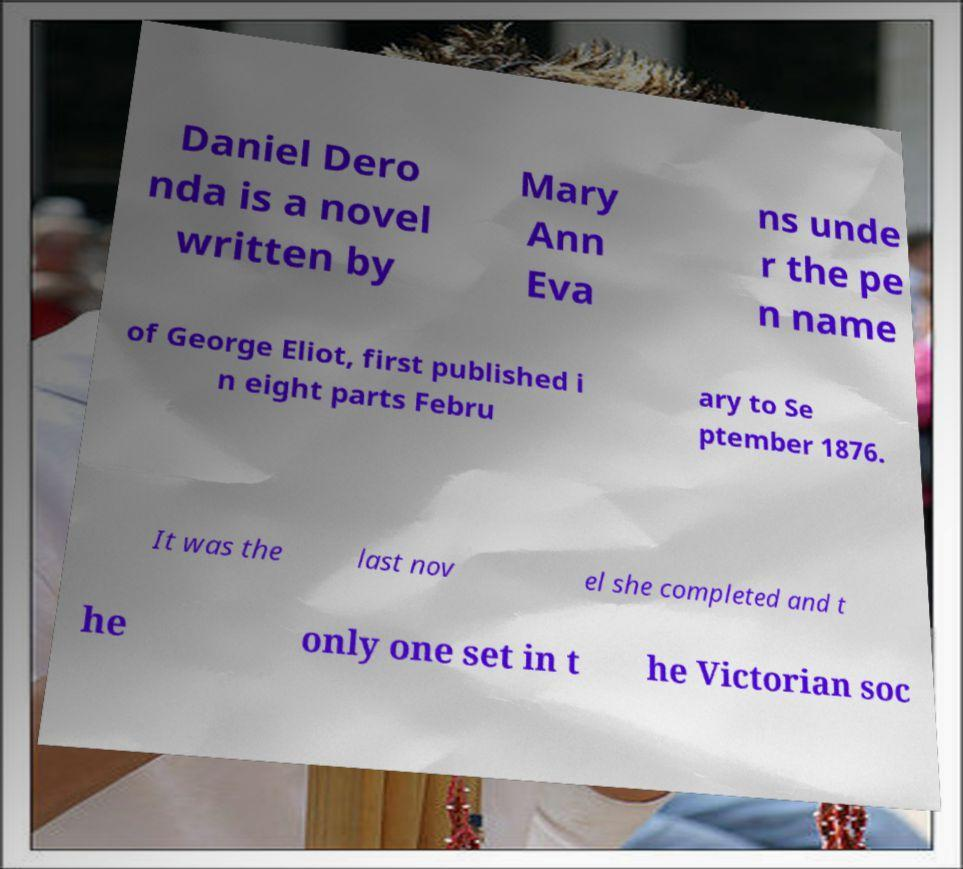For documentation purposes, I need the text within this image transcribed. Could you provide that? Daniel Dero nda is a novel written by Mary Ann Eva ns unde r the pe n name of George Eliot, first published i n eight parts Febru ary to Se ptember 1876. It was the last nov el she completed and t he only one set in t he Victorian soc 